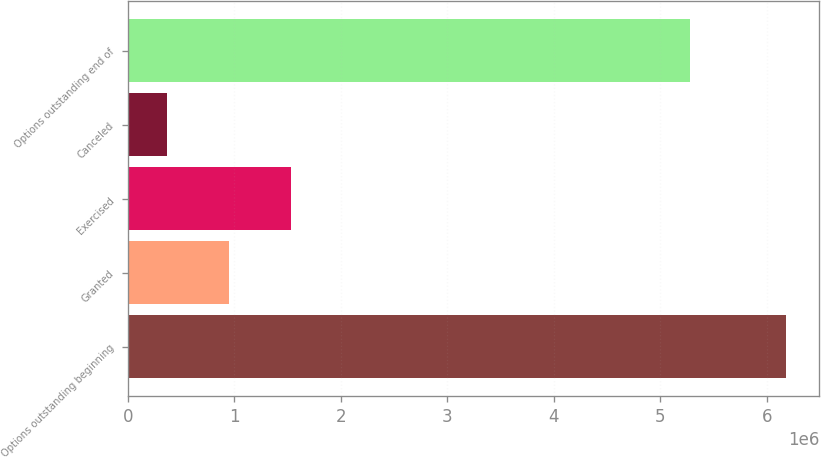Convert chart to OTSL. <chart><loc_0><loc_0><loc_500><loc_500><bar_chart><fcel>Options outstanding beginning<fcel>Granted<fcel>Exercised<fcel>Canceled<fcel>Options outstanding end of<nl><fcel>6.18302e+06<fcel>950583<fcel>1.53196e+06<fcel>369202<fcel>5.27357e+06<nl></chart> 